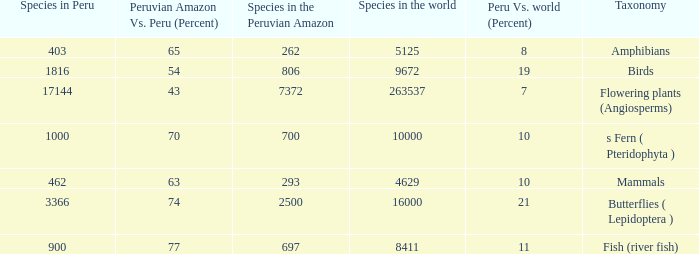What's the minimum species in the peruvian amazon with species in peru of 1000 700.0. 